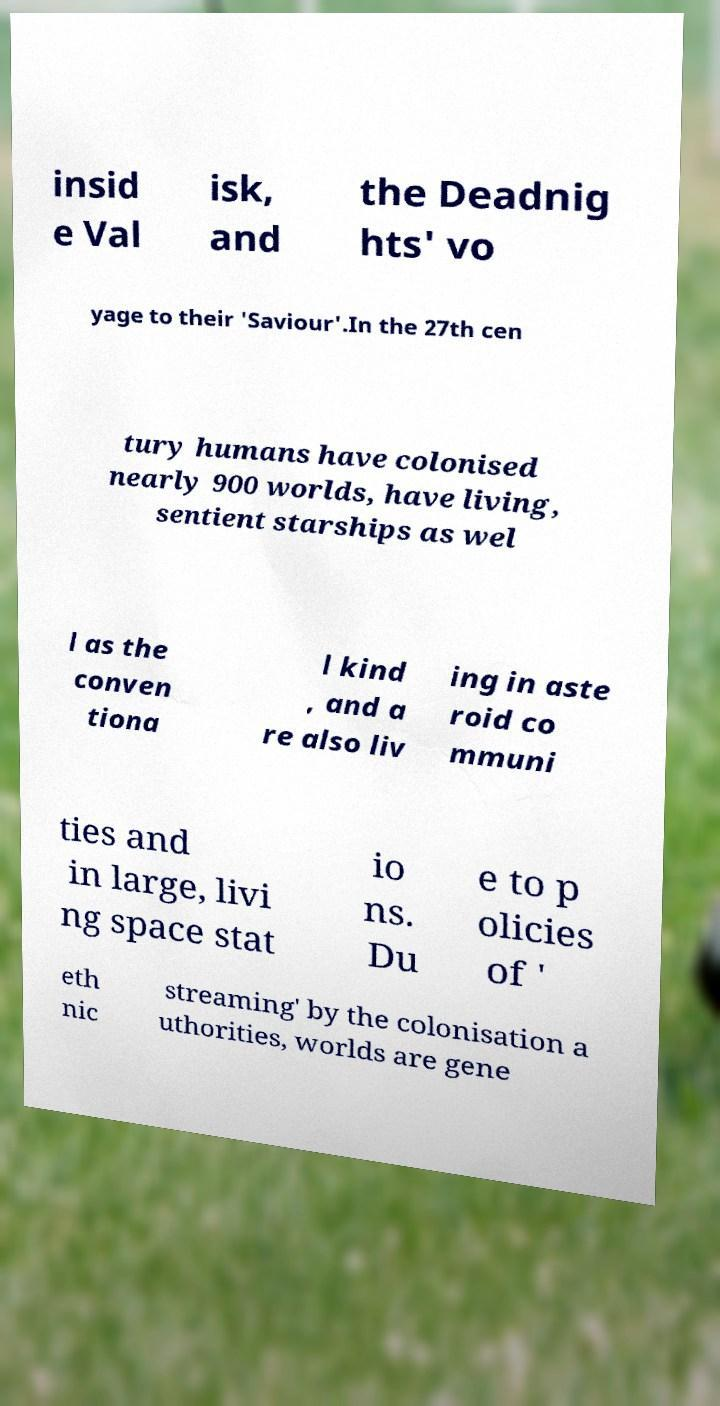Please identify and transcribe the text found in this image. insid e Val isk, and the Deadnig hts' vo yage to their 'Saviour'.In the 27th cen tury humans have colonised nearly 900 worlds, have living, sentient starships as wel l as the conven tiona l kind , and a re also liv ing in aste roid co mmuni ties and in large, livi ng space stat io ns. Du e to p olicies of ' eth nic streaming' by the colonisation a uthorities, worlds are gene 